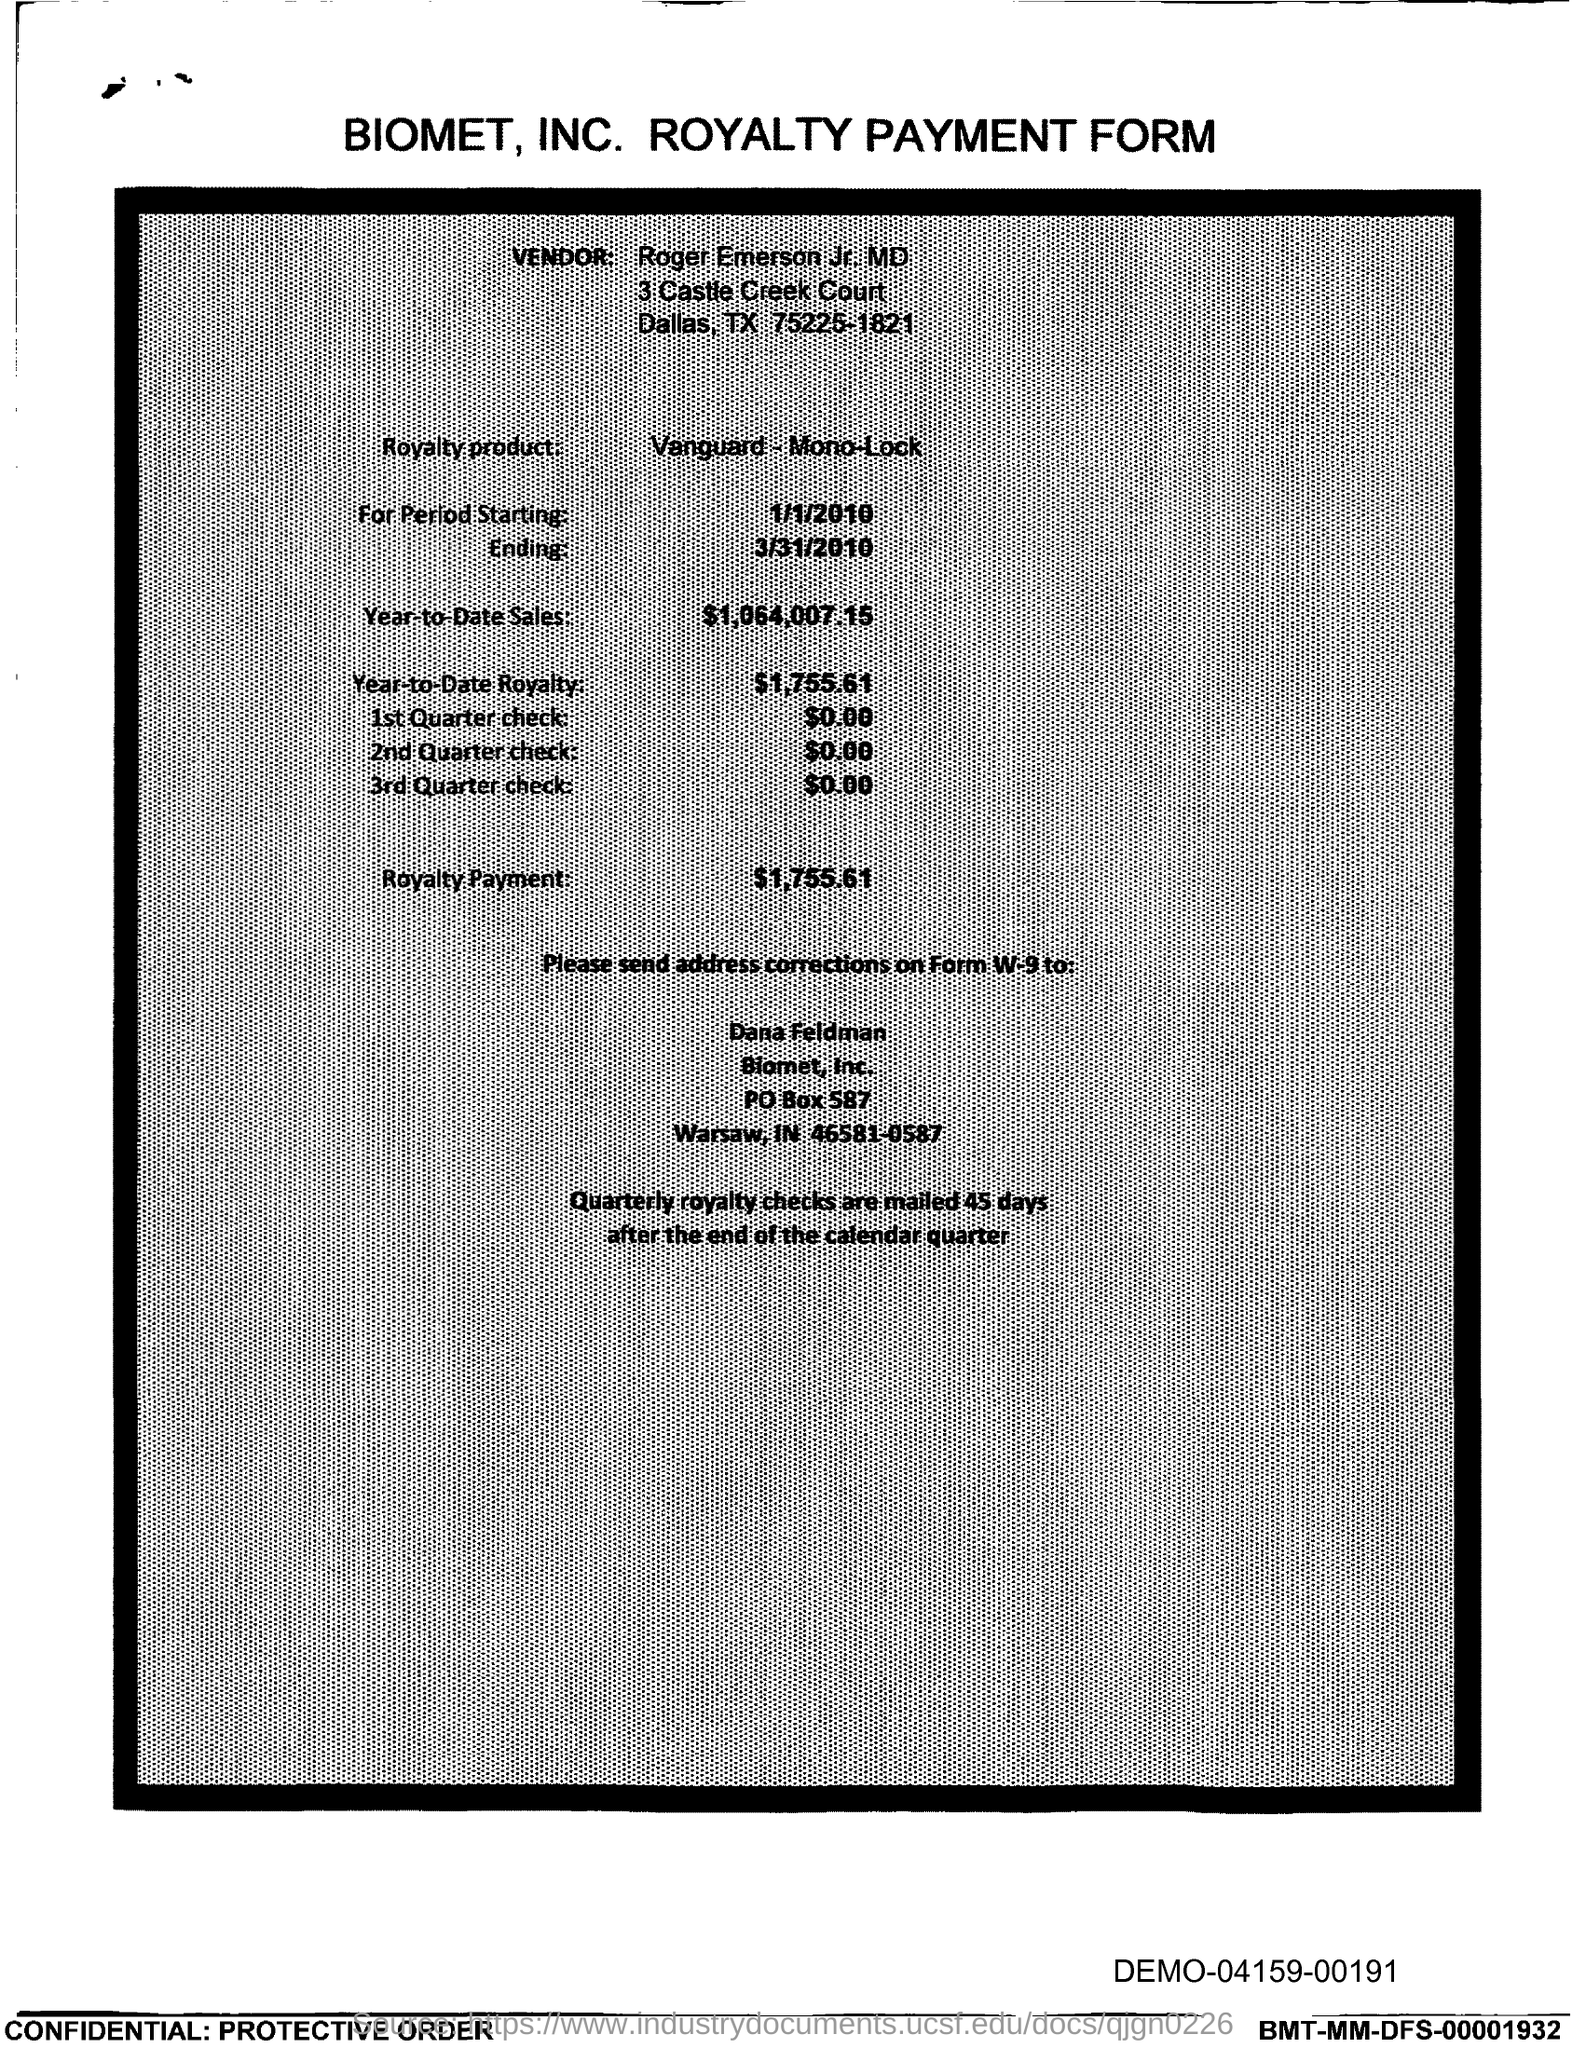Outline some significant characteristics in this image. I am not sure what you are asking for. A "PO box" is a post office box, and "Biomet, Inc." is a company name. Could you please provide more context or clarify your question? Biomet, Inc. is located in the state of Indiana. The royalty payment is $1,755.61. The year-to-date royalty is $1,755.61. The year-to-date sales as of February 26, 2023, are $1,064,007.15. 